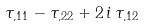Convert formula to latex. <formula><loc_0><loc_0><loc_500><loc_500>\tau _ { , 1 1 } - \tau _ { , 2 2 } + 2 \, i \, \tau _ { , 1 2 }</formula> 